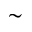Convert formula to latex. <formula><loc_0><loc_0><loc_500><loc_500>\sim</formula> 